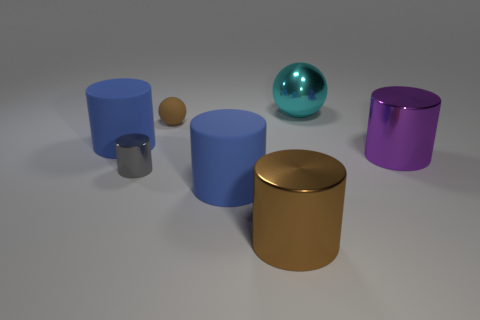Subtract all blue spheres. How many blue cylinders are left? 2 Subtract all purple cylinders. How many cylinders are left? 4 Subtract all small metal cylinders. How many cylinders are left? 4 Add 2 balls. How many objects exist? 9 Subtract all yellow cylinders. Subtract all blue blocks. How many cylinders are left? 5 Subtract all balls. How many objects are left? 5 Subtract all matte balls. Subtract all large brown metal cylinders. How many objects are left? 5 Add 5 gray cylinders. How many gray cylinders are left? 6 Add 2 big metal things. How many big metal things exist? 5 Subtract 1 brown spheres. How many objects are left? 6 